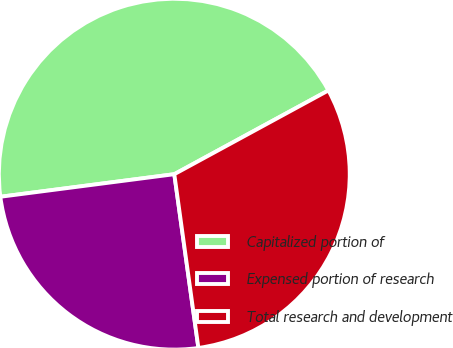Convert chart to OTSL. <chart><loc_0><loc_0><loc_500><loc_500><pie_chart><fcel>Capitalized portion of<fcel>Expensed portion of research<fcel>Total research and development<nl><fcel>44.13%<fcel>25.14%<fcel>30.73%<nl></chart> 